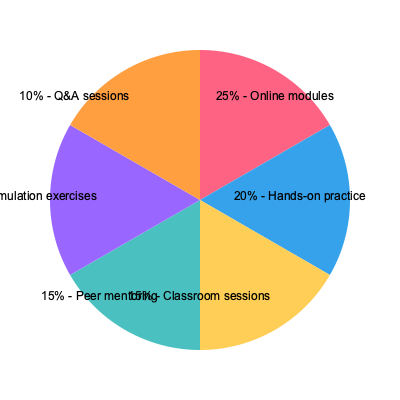Based on the pie chart showing the distribution of staff training methods for EHR adoption, what percentage of the training schedule is allocated to interactive learning methods (hands-on practice, peer mentoring, and simulation exercises combined)? To determine the percentage of the training schedule allocated to interactive learning methods, we need to follow these steps:

1. Identify the interactive learning methods from the pie chart:
   - Hands-on practice: 20%
   - Peer mentoring: 15%
   - Simulation exercises: 15%

2. Sum up the percentages for these interactive methods:
   $20\% + 15\% + 15\% = 50\%$

3. Verify that the total adds up to 100%:
   Online modules (25%) + Hands-on practice (20%) + Classroom sessions (15%) + Peer mentoring (15%) + Simulation exercises (15%) + Q&A sessions (10%) = 100%

4. Conclude that the interactive learning methods (hands-on practice, peer mentoring, and simulation exercises) account for 50% of the total training schedule.

This distribution emphasizes the importance of practical, interactive learning in EHR adoption, which is crucial for ensuring staff competency and confidence in using the new system.
Answer: 50% 